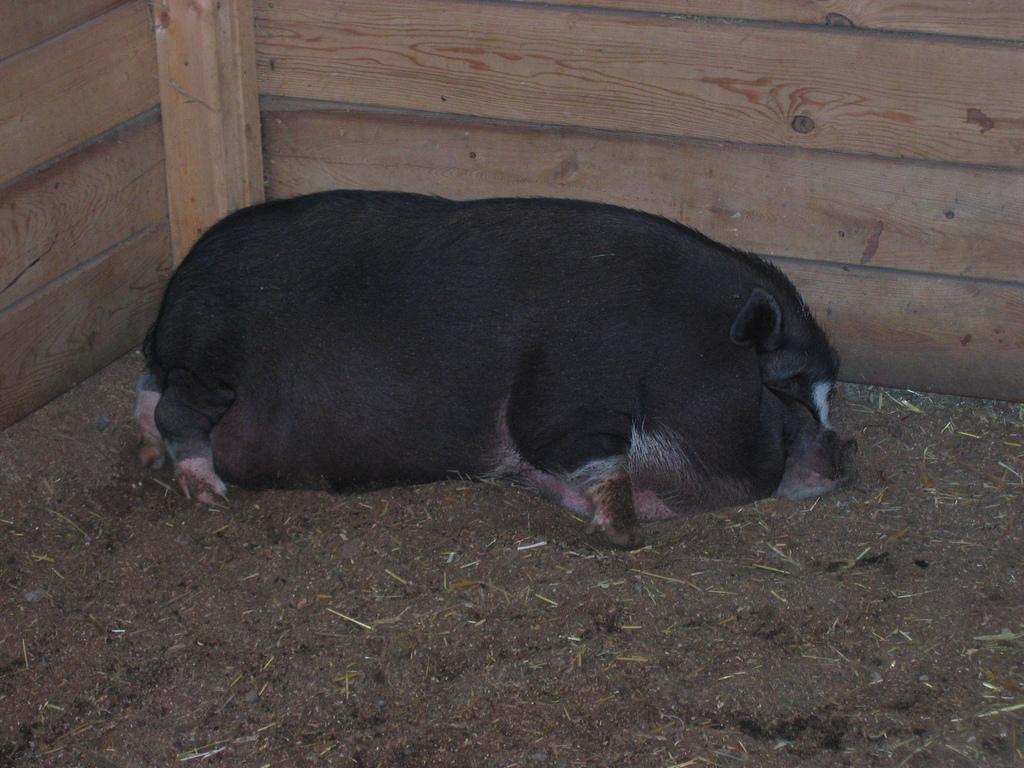In one or two sentences, can you explain what this image depicts? In this picture, we can see an animal lying on the ground, and we can see wooden object in the background. 